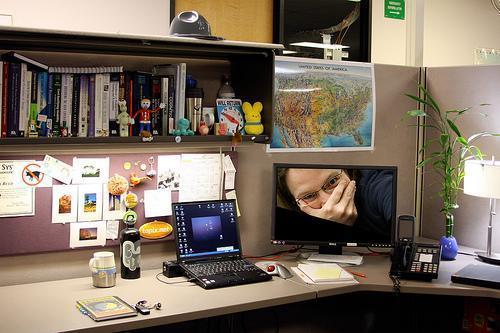How many plants are on the desk?
Give a very brief answer. 1. How many people are typing computer?
Give a very brief answer. 0. 